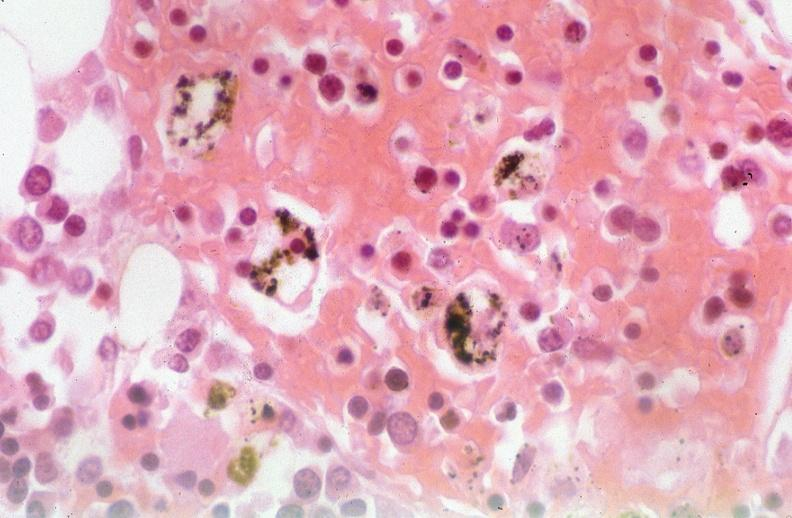what was used to sclerose emphysematous lung, alpha-1 antitrypsin deficiency?
Answer the question using a single word or phrase. Talc 